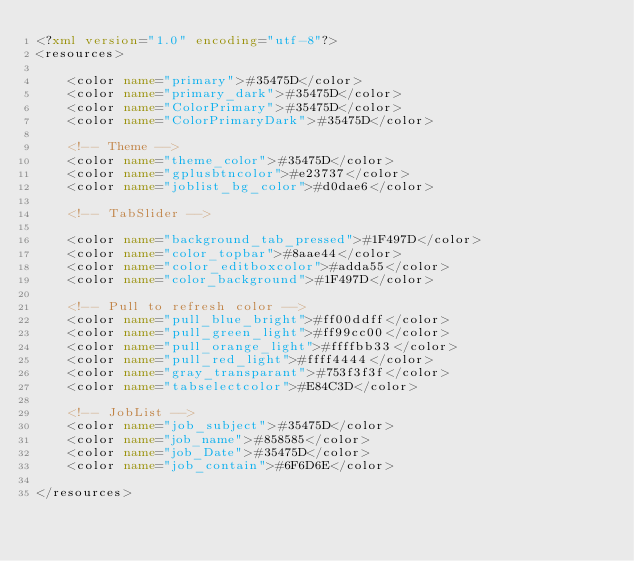Convert code to text. <code><loc_0><loc_0><loc_500><loc_500><_XML_><?xml version="1.0" encoding="utf-8"?>
<resources>

    <color name="primary">#35475D</color>
    <color name="primary_dark">#35475D</color>
    <color name="ColorPrimary">#35475D</color>
    <color name="ColorPrimaryDark">#35475D</color>

    <!-- Theme -->
    <color name="theme_color">#35475D</color>
    <color name="gplusbtncolor">#e23737</color>
    <color name="joblist_bg_color">#d0dae6</color>

    <!-- TabSlider -->

    <color name="background_tab_pressed">#1F497D</color>
    <color name="color_topbar">#8aae44</color>
    <color name="color_editboxcolor">#adda55</color>
    <color name="color_background">#1F497D</color>

    <!-- Pull to refresh color -->
    <color name="pull_blue_bright">#ff00ddff</color>
    <color name="pull_green_light">#ff99cc00</color>
    <color name="pull_orange_light">#ffffbb33</color>
    <color name="pull_red_light">#ffff4444</color>
    <color name="gray_transparant">#753f3f3f</color>
    <color name="tabselectcolor">#E84C3D</color>

    <!-- JobList -->
    <color name="job_subject">#35475D</color>
    <color name="job_name">#858585</color>
    <color name="job_Date">#35475D</color>
    <color name="job_contain">#6F6D6E</color>

</resources></code> 